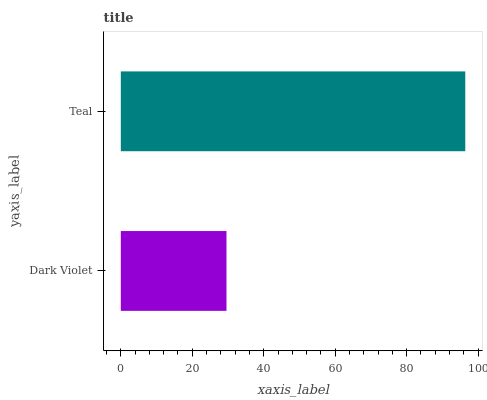Is Dark Violet the minimum?
Answer yes or no. Yes. Is Teal the maximum?
Answer yes or no. Yes. Is Teal the minimum?
Answer yes or no. No. Is Teal greater than Dark Violet?
Answer yes or no. Yes. Is Dark Violet less than Teal?
Answer yes or no. Yes. Is Dark Violet greater than Teal?
Answer yes or no. No. Is Teal less than Dark Violet?
Answer yes or no. No. Is Teal the high median?
Answer yes or no. Yes. Is Dark Violet the low median?
Answer yes or no. Yes. Is Dark Violet the high median?
Answer yes or no. No. Is Teal the low median?
Answer yes or no. No. 